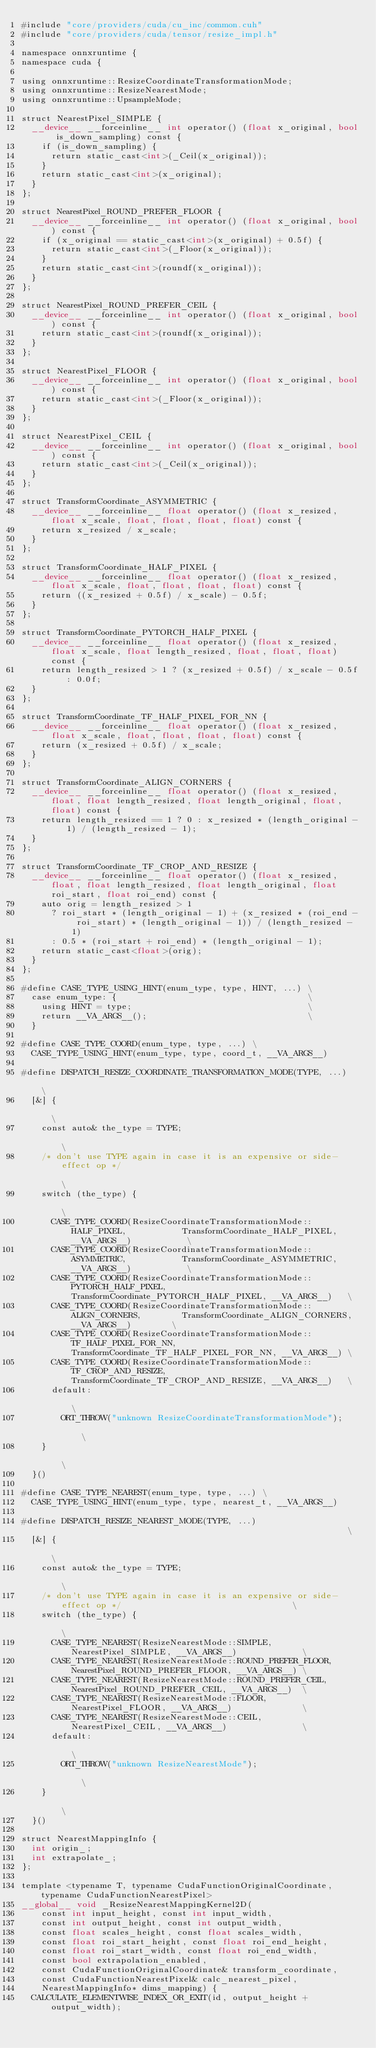<code> <loc_0><loc_0><loc_500><loc_500><_Cuda_>#include "core/providers/cuda/cu_inc/common.cuh"
#include "core/providers/cuda/tensor/resize_impl.h"

namespace onnxruntime {
namespace cuda {

using onnxruntime::ResizeCoordinateTransformationMode;
using onnxruntime::ResizeNearestMode;
using onnxruntime::UpsampleMode;

struct NearestPixel_SIMPLE {
  __device__ __forceinline__ int operator() (float x_original, bool is_down_sampling) const {
    if (is_down_sampling) {
      return static_cast<int>(_Ceil(x_original));
    }
    return static_cast<int>(x_original);
  }
};

struct NearestPixel_ROUND_PREFER_FLOOR {
  __device__ __forceinline__ int operator() (float x_original, bool) const {
    if (x_original == static_cast<int>(x_original) + 0.5f) {
      return static_cast<int>(_Floor(x_original));
    }
    return static_cast<int>(roundf(x_original));
  }
};

struct NearestPixel_ROUND_PREFER_CEIL {
  __device__ __forceinline__ int operator() (float x_original, bool) const {
    return static_cast<int>(roundf(x_original));
  }
};

struct NearestPixel_FLOOR {
  __device__ __forceinline__ int operator() (float x_original, bool) const {
    return static_cast<int>(_Floor(x_original));
  }
};

struct NearestPixel_CEIL {
  __device__ __forceinline__ int operator() (float x_original, bool) const {
    return static_cast<int>(_Ceil(x_original));
  }
};

struct TransformCoordinate_ASYMMETRIC {
  __device__ __forceinline__ float operator() (float x_resized, float x_scale, float, float, float, float) const {
    return x_resized / x_scale;
  }
};

struct TransformCoordinate_HALF_PIXEL {
  __device__ __forceinline__ float operator() (float x_resized, float x_scale, float, float, float, float) const {
    return ((x_resized + 0.5f) / x_scale) - 0.5f;
  }
};

struct TransformCoordinate_PYTORCH_HALF_PIXEL {
  __device__ __forceinline__ float operator() (float x_resized, float x_scale, float length_resized, float, float, float) const {
    return length_resized > 1 ? (x_resized + 0.5f) / x_scale - 0.5f : 0.0f;
  }
};

struct TransformCoordinate_TF_HALF_PIXEL_FOR_NN {
  __device__ __forceinline__ float operator() (float x_resized, float x_scale, float, float, float, float) const {
    return (x_resized + 0.5f) / x_scale;
  }
};

struct TransformCoordinate_ALIGN_CORNERS {
  __device__ __forceinline__ float operator() (float x_resized, float, float length_resized, float length_original, float, float) const {
    return length_resized == 1 ? 0 : x_resized * (length_original - 1) / (length_resized - 1);
  }
};

struct TransformCoordinate_TF_CROP_AND_RESIZE {
  __device__ __forceinline__ float operator() (float x_resized, float, float length_resized, float length_original, float roi_start, float roi_end) const {
    auto orig = length_resized > 1
      ? roi_start * (length_original - 1) + (x_resized * (roi_end - roi_start) * (length_original - 1)) / (length_resized - 1)
      : 0.5 * (roi_start + roi_end) * (length_original - 1);
    return static_cast<float>(orig);
  }
};

#define CASE_TYPE_USING_HINT(enum_type, type, HINT, ...) \
  case enum_type: {                                      \
    using HINT = type;                                   \
    return __VA_ARGS__();                                \
  }

#define CASE_TYPE_COORD(enum_type, type, ...) \
  CASE_TYPE_USING_HINT(enum_type, type, coord_t, __VA_ARGS__)

#define DISPATCH_RESIZE_COORDINATE_TRANSFORMATION_MODE(TYPE, ...)                                                                      \
  [&] {                                                                                                                                \
    const auto& the_type = TYPE;                                                                                                       \
    /* don't use TYPE again in case it is an expensive or side-effect op */                                                            \
    switch (the_type) {                                                                                                                \
      CASE_TYPE_COORD(ResizeCoordinateTransformationMode::HALF_PIXEL,           TransformCoordinate_HALF_PIXEL, __VA_ARGS__)           \
      CASE_TYPE_COORD(ResizeCoordinateTransformationMode::ASYMMETRIC,           TransformCoordinate_ASYMMETRIC, __VA_ARGS__)           \
      CASE_TYPE_COORD(ResizeCoordinateTransformationMode::PYTORCH_HALF_PIXEL,   TransformCoordinate_PYTORCH_HALF_PIXEL, __VA_ARGS__)   \
      CASE_TYPE_COORD(ResizeCoordinateTransformationMode::ALIGN_CORNERS,        TransformCoordinate_ALIGN_CORNERS, __VA_ARGS__)        \
      CASE_TYPE_COORD(ResizeCoordinateTransformationMode::TF_HALF_PIXEL_FOR_NN, TransformCoordinate_TF_HALF_PIXEL_FOR_NN, __VA_ARGS__) \
      CASE_TYPE_COORD(ResizeCoordinateTransformationMode::TF_CROP_AND_RESIZE,   TransformCoordinate_TF_CROP_AND_RESIZE, __VA_ARGS__)   \
      default:                                                                                                                         \
        ORT_THROW("unknown ResizeCoordinateTransformationMode");                                                                       \
    }                                                                                                                                  \
  }()

#define CASE_TYPE_NEAREST(enum_type, type, ...) \
  CASE_TYPE_USING_HINT(enum_type, type, nearest_t, __VA_ARGS__)

#define DISPATCH_RESIZE_NEAREST_MODE(TYPE, ...)                                                              \
  [&] {                                                                                                      \
    const auto& the_type = TYPE;                                                                             \
    /* don't use TYPE again in case it is an expensive or side-effect op */                                  \
    switch (the_type) {                                                                                      \
      CASE_TYPE_NEAREST(ResizeNearestMode::SIMPLE,             NearestPixel_SIMPLE, __VA_ARGS__)             \
      CASE_TYPE_NEAREST(ResizeNearestMode::ROUND_PREFER_FLOOR, NearestPixel_ROUND_PREFER_FLOOR, __VA_ARGS__) \
      CASE_TYPE_NEAREST(ResizeNearestMode::ROUND_PREFER_CEIL,  NearestPixel_ROUND_PREFER_CEIL, __VA_ARGS__)  \
      CASE_TYPE_NEAREST(ResizeNearestMode::FLOOR,              NearestPixel_FLOOR, __VA_ARGS__)              \
      CASE_TYPE_NEAREST(ResizeNearestMode::CEIL,               NearestPixel_CEIL, __VA_ARGS__)               \
      default:                                                                                               \
        ORT_THROW("unknown ResizeNearestMode");                                                              \
    }                                                                                                        \
  }()

struct NearestMappingInfo {
  int origin_;
  int extrapolate_;
};

template <typename T, typename CudaFunctionOriginalCoordinate, typename CudaFunctionNearestPixel>
__global__ void _ResizeNearestMappingKernel2D(
    const int input_height, const int input_width,
    const int output_height, const int output_width,
    const float scales_height, const float scales_width,
    const float roi_start_height, const float roi_end_height,
    const float roi_start_width, const float roi_end_width,
    const bool extrapolation_enabled,
    const CudaFunctionOriginalCoordinate& transform_coordinate,
    const CudaFunctionNearestPixel& calc_nearest_pixel,
    NearestMappingInfo* dims_mapping) {
  CALCULATE_ELEMENTWISE_INDEX_OR_EXIT(id, output_height + output_width);</code> 